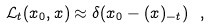<formula> <loc_0><loc_0><loc_500><loc_500>\mathcal { L } _ { t } ( x _ { 0 } , x ) \approx \delta ( x _ { 0 } - ( x ) _ { - t } ) \ ,</formula> 